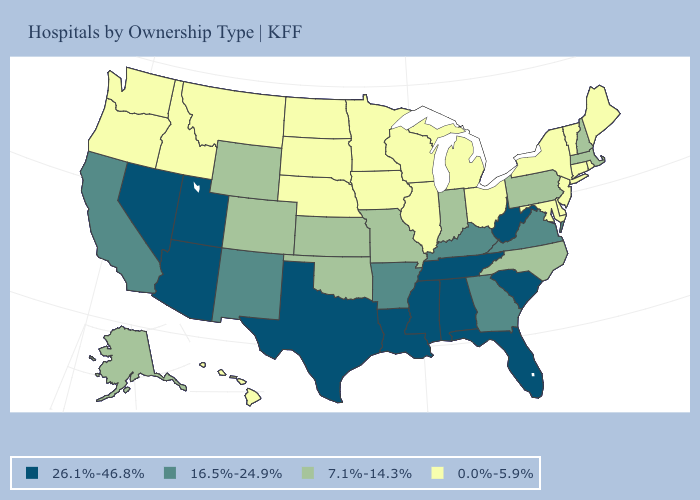Name the states that have a value in the range 7.1%-14.3%?
Give a very brief answer. Alaska, Colorado, Indiana, Kansas, Massachusetts, Missouri, New Hampshire, North Carolina, Oklahoma, Pennsylvania, Wyoming. What is the lowest value in the USA?
Answer briefly. 0.0%-5.9%. What is the lowest value in the USA?
Write a very short answer. 0.0%-5.9%. What is the value of Nevada?
Answer briefly. 26.1%-46.8%. What is the value of Washington?
Short answer required. 0.0%-5.9%. Name the states that have a value in the range 7.1%-14.3%?
Short answer required. Alaska, Colorado, Indiana, Kansas, Massachusetts, Missouri, New Hampshire, North Carolina, Oklahoma, Pennsylvania, Wyoming. Among the states that border Ohio , which have the lowest value?
Concise answer only. Michigan. Is the legend a continuous bar?
Write a very short answer. No. Among the states that border Florida , which have the lowest value?
Concise answer only. Georgia. Name the states that have a value in the range 7.1%-14.3%?
Short answer required. Alaska, Colorado, Indiana, Kansas, Massachusetts, Missouri, New Hampshire, North Carolina, Oklahoma, Pennsylvania, Wyoming. Does the map have missing data?
Be succinct. No. Does Kentucky have the same value as Vermont?
Short answer required. No. Which states have the lowest value in the South?
Be succinct. Delaware, Maryland. Name the states that have a value in the range 0.0%-5.9%?
Answer briefly. Connecticut, Delaware, Hawaii, Idaho, Illinois, Iowa, Maine, Maryland, Michigan, Minnesota, Montana, Nebraska, New Jersey, New York, North Dakota, Ohio, Oregon, Rhode Island, South Dakota, Vermont, Washington, Wisconsin. Among the states that border Kentucky , which have the highest value?
Concise answer only. Tennessee, West Virginia. 